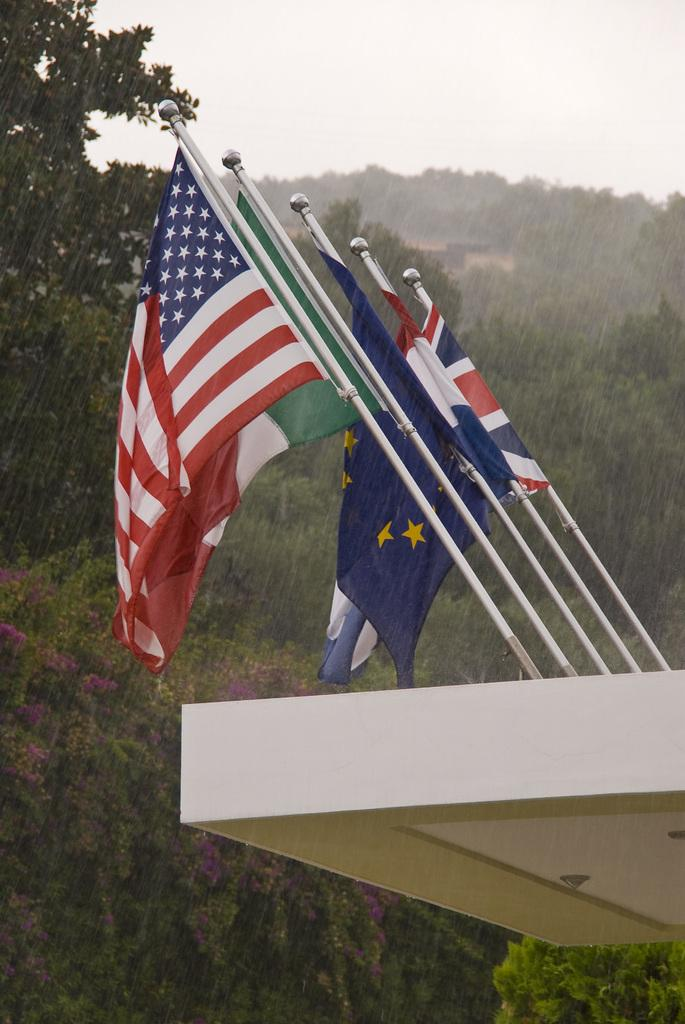What is the weather condition in the image? The image was taken during rain. What can be seen in the foreground of the image? There are flags in the foreground of the image. What type of vegetation is visible in the background of the image? There are trees in the background of the image. What is visible in the sky in the image? The sky is visible in the background of the image. What type of owl can be seen perched on the hydrant in the image? There is no owl or hydrant present in the image. What question is being asked by the person in the image? There is no person visible in the image, so it is not possible to determine what question they might be asking. 